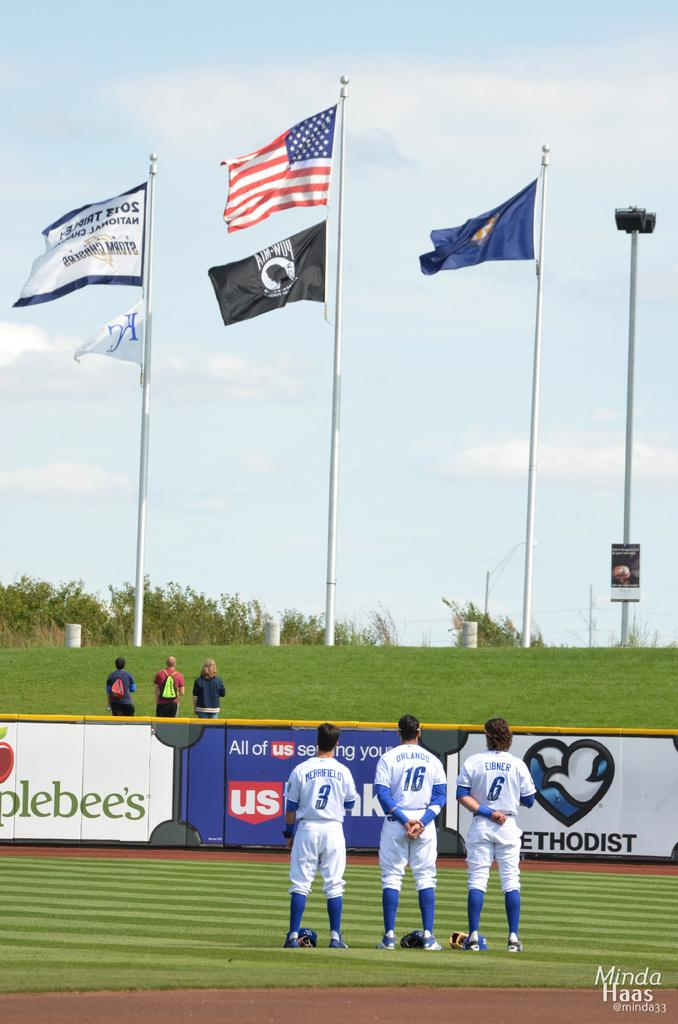<image>
Describe the image concisely. Baseball players wearing the numbers 3, 16 and 6 gather in the outfield to honor the United States of America. 